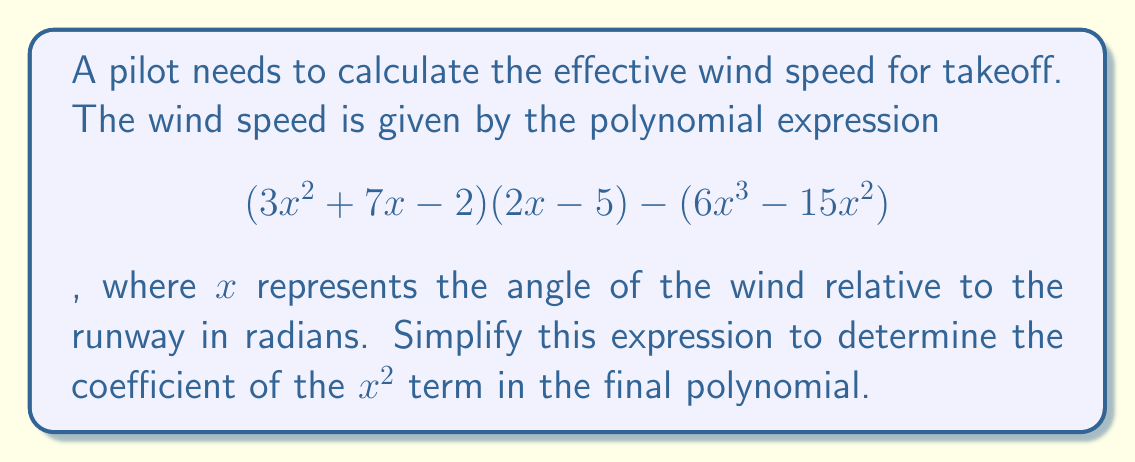Show me your answer to this math problem. Let's approach this step-by-step:

1) First, let's expand $(3x^2 + 7x - 2)(2x - 5)$:
   $$(3x^2 + 7x - 2)(2x - 5) = 6x^3 - 15x^2 + 14x^2 - 35x - 4x + 10$$
   $$= 6x^3 - x^2 - 39x + 10$$

2) Now our expression becomes:
   $$(6x^3 - x^2 - 39x + 10) - (6x^3 - 15x^2)$$

3) Let's subtract these polynomials:
   $$6x^3 - x^2 - 39x + 10$$
   $$-(6x^3 - 15x^2)$$
   $$= 6x^3 - x^2 - 39x + 10 - 6x^3 + 15x^2$$

4) Simplify by combining like terms:
   $$= (6x^3 - 6x^3) + (-x^2 + 15x^2) + (-39x) + 10$$
   $$= 0 + 14x^2 - 39x + 10$$

5) Therefore, the simplified polynomial is:
   $$14x^2 - 39x + 10$$

6) The coefficient of the $x^2$ term in this final polynomial is 14.
Answer: 14 